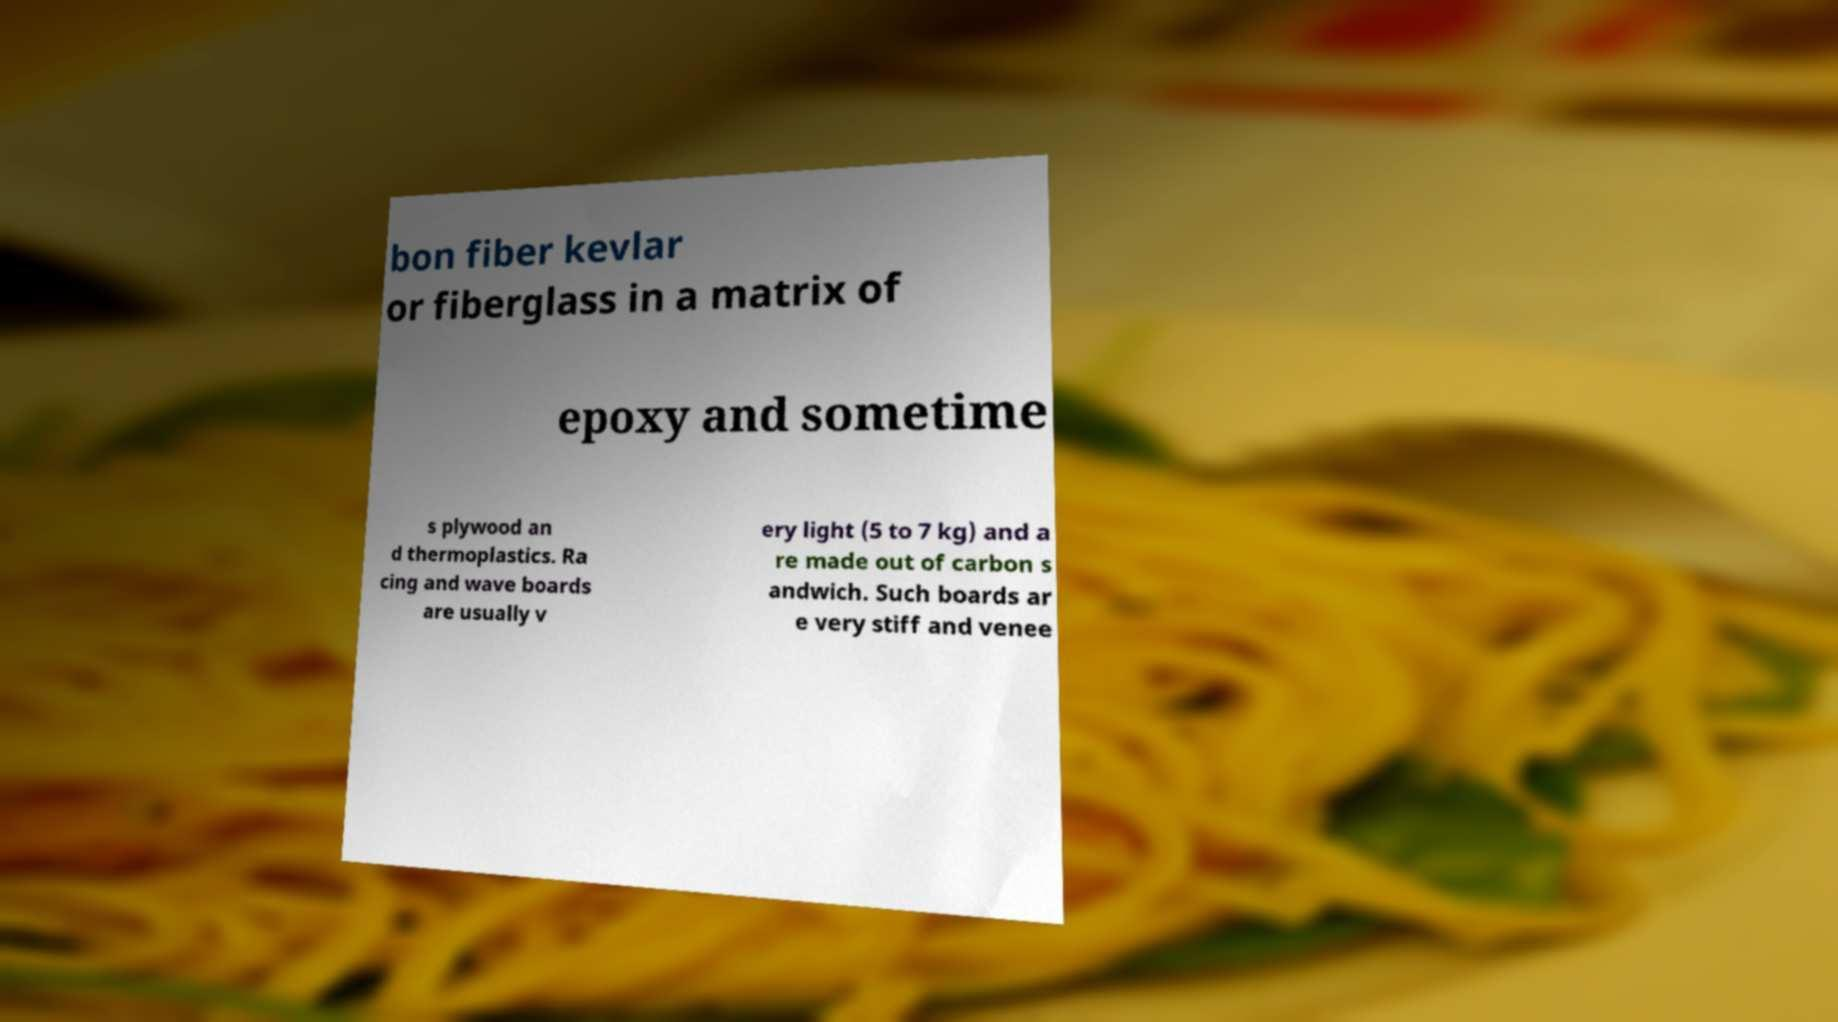I need the written content from this picture converted into text. Can you do that? bon fiber kevlar or fiberglass in a matrix of epoxy and sometime s plywood an d thermoplastics. Ra cing and wave boards are usually v ery light (5 to 7 kg) and a re made out of carbon s andwich. Such boards ar e very stiff and venee 